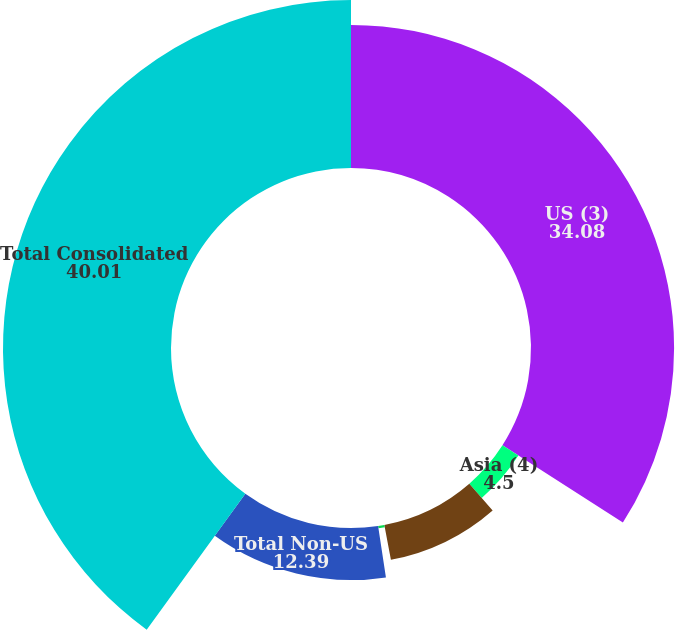Convert chart to OTSL. <chart><loc_0><loc_0><loc_500><loc_500><pie_chart><fcel>US (3)<fcel>Asia (4)<fcel>Europe Middle East and Africa<fcel>Latin America and the<fcel>Total Non-US<fcel>Total Consolidated<nl><fcel>34.08%<fcel>4.5%<fcel>8.45%<fcel>0.56%<fcel>12.39%<fcel>40.01%<nl></chart> 